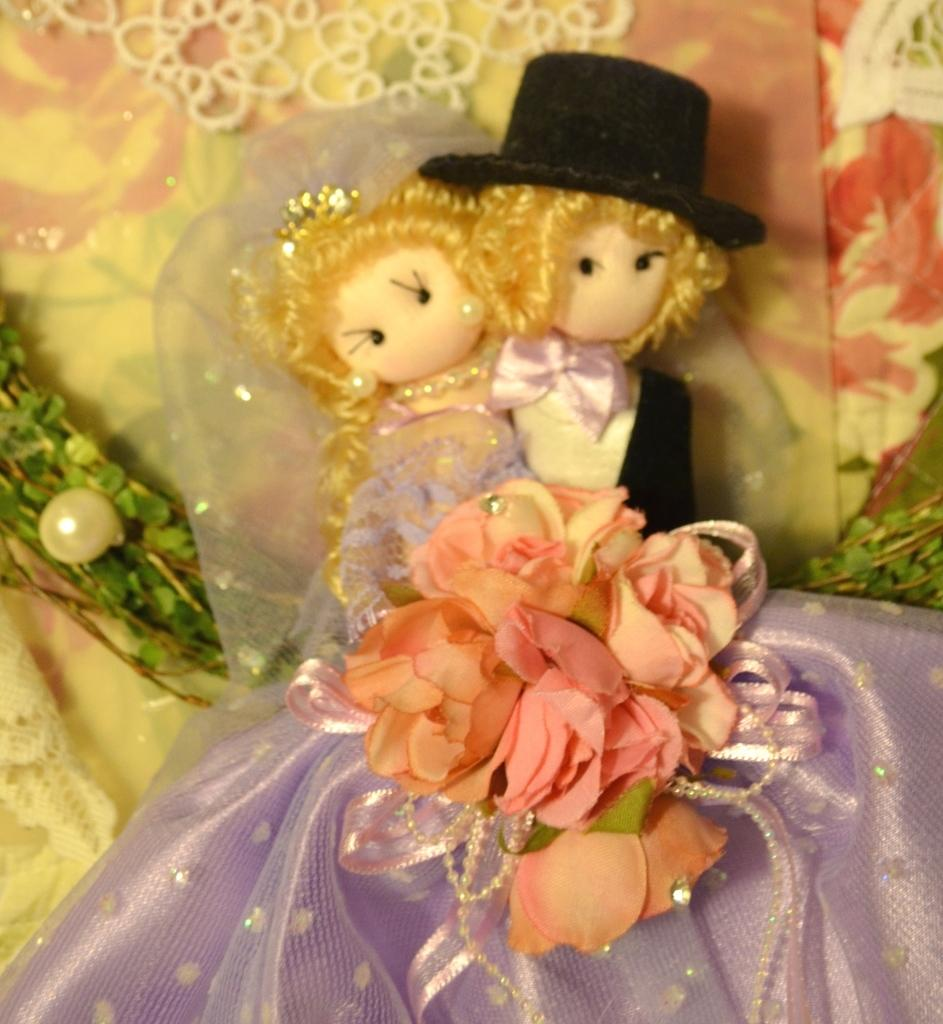What is the main subject in the center of the image? There is a figurine in the center of the image. How many pickles are hanging from the bridge in the image? There is no bridge or pickles present in the image; it only features a figurine. 